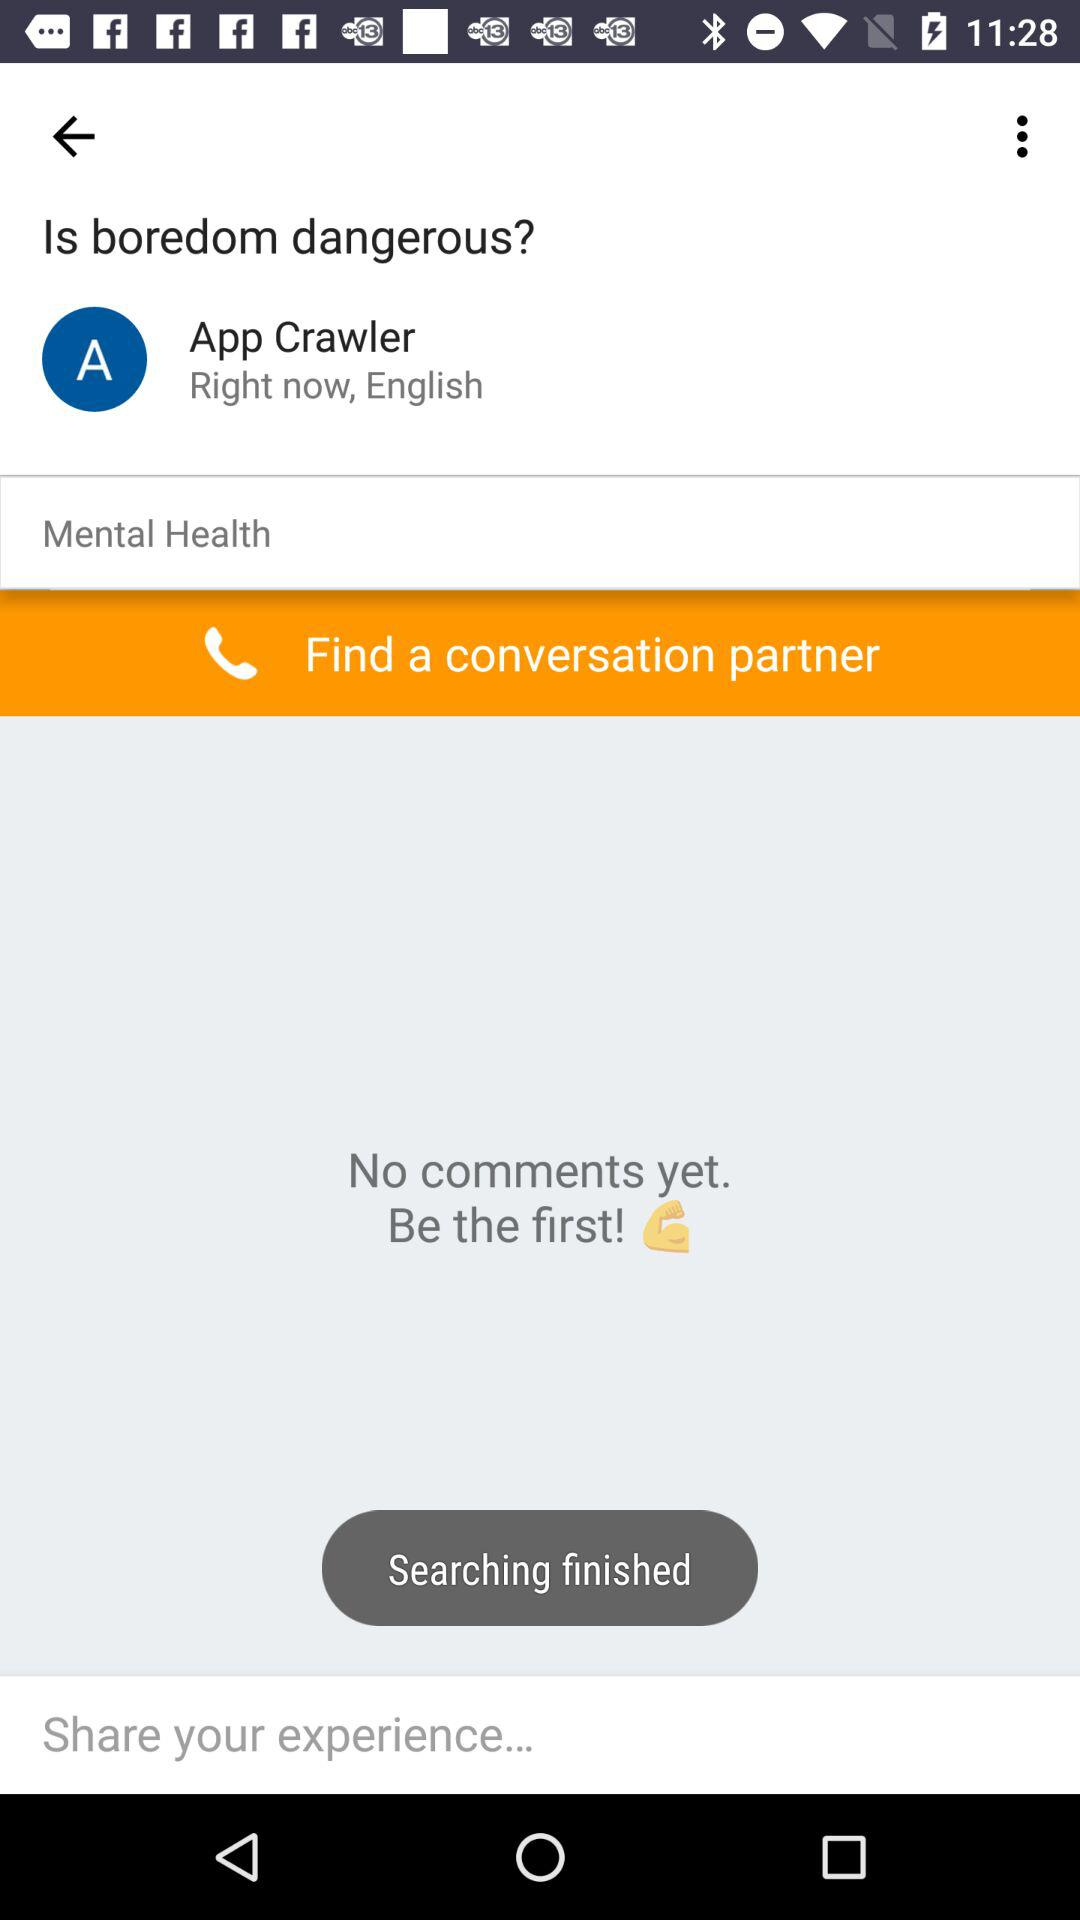Can you give advice on how to engage with this type of app? To engage with this app, you would likely start by reading the post and then contribute to the discussion by sharing your thoughts or experiences. It's important to be respectful and considerate, as the topic falls under mental health. 